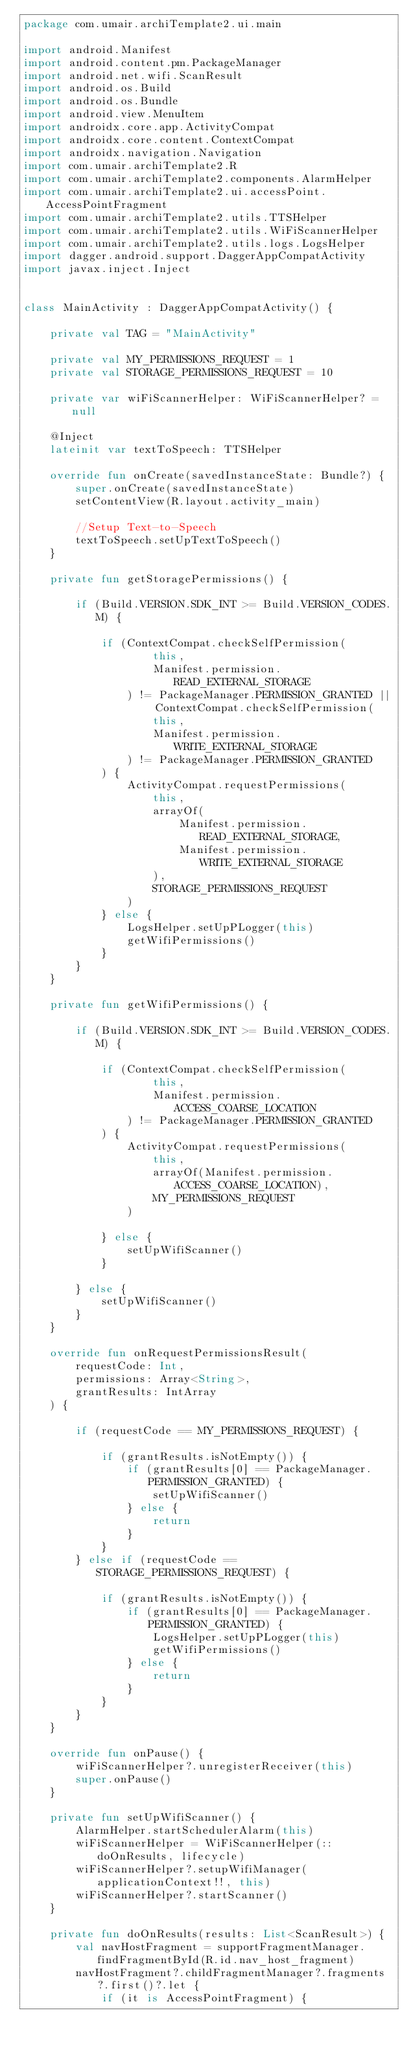<code> <loc_0><loc_0><loc_500><loc_500><_Kotlin_>package com.umair.archiTemplate2.ui.main

import android.Manifest
import android.content.pm.PackageManager
import android.net.wifi.ScanResult
import android.os.Build
import android.os.Bundle
import android.view.MenuItem
import androidx.core.app.ActivityCompat
import androidx.core.content.ContextCompat
import androidx.navigation.Navigation
import com.umair.archiTemplate2.R
import com.umair.archiTemplate2.components.AlarmHelper
import com.umair.archiTemplate2.ui.accessPoint.AccessPointFragment
import com.umair.archiTemplate2.utils.TTSHelper
import com.umair.archiTemplate2.utils.WiFiScannerHelper
import com.umair.archiTemplate2.utils.logs.LogsHelper
import dagger.android.support.DaggerAppCompatActivity
import javax.inject.Inject


class MainActivity : DaggerAppCompatActivity() {

    private val TAG = "MainActivity"

    private val MY_PERMISSIONS_REQUEST = 1
    private val STORAGE_PERMISSIONS_REQUEST = 10

    private var wiFiScannerHelper: WiFiScannerHelper? = null

    @Inject
    lateinit var textToSpeech: TTSHelper

    override fun onCreate(savedInstanceState: Bundle?) {
        super.onCreate(savedInstanceState)
        setContentView(R.layout.activity_main)

        //Setup Text-to-Speech
        textToSpeech.setUpTextToSpeech()
    }

    private fun getStoragePermissions() {

        if (Build.VERSION.SDK_INT >= Build.VERSION_CODES.M) {

            if (ContextCompat.checkSelfPermission(
                    this,
                    Manifest.permission.READ_EXTERNAL_STORAGE
                ) != PackageManager.PERMISSION_GRANTED || ContextCompat.checkSelfPermission(
                    this,
                    Manifest.permission.WRITE_EXTERNAL_STORAGE
                ) != PackageManager.PERMISSION_GRANTED
            ) {
                ActivityCompat.requestPermissions(
                    this,
                    arrayOf(
                        Manifest.permission.READ_EXTERNAL_STORAGE,
                        Manifest.permission.WRITE_EXTERNAL_STORAGE
                    ),
                    STORAGE_PERMISSIONS_REQUEST
                )
            } else {
                LogsHelper.setUpPLogger(this)
                getWifiPermissions()
            }
        }
    }

    private fun getWifiPermissions() {

        if (Build.VERSION.SDK_INT >= Build.VERSION_CODES.M) {

            if (ContextCompat.checkSelfPermission(
                    this,
                    Manifest.permission.ACCESS_COARSE_LOCATION
                ) != PackageManager.PERMISSION_GRANTED
            ) {
                ActivityCompat.requestPermissions(
                    this,
                    arrayOf(Manifest.permission.ACCESS_COARSE_LOCATION),
                    MY_PERMISSIONS_REQUEST
                )

            } else {
                setUpWifiScanner()
            }

        } else {
            setUpWifiScanner()
        }
    }

    override fun onRequestPermissionsResult(
        requestCode: Int,
        permissions: Array<String>,
        grantResults: IntArray
    ) {

        if (requestCode == MY_PERMISSIONS_REQUEST) {

            if (grantResults.isNotEmpty()) {
                if (grantResults[0] == PackageManager.PERMISSION_GRANTED) {
                    setUpWifiScanner()
                } else {
                    return
                }
            }
        } else if (requestCode == STORAGE_PERMISSIONS_REQUEST) {

            if (grantResults.isNotEmpty()) {
                if (grantResults[0] == PackageManager.PERMISSION_GRANTED) {
                    LogsHelper.setUpPLogger(this)
                    getWifiPermissions()
                } else {
                    return
                }
            }
        }
    }

    override fun onPause() {
        wiFiScannerHelper?.unregisterReceiver(this)
        super.onPause()
    }

    private fun setUpWifiScanner() {
        AlarmHelper.startSchedulerAlarm(this)
        wiFiScannerHelper = WiFiScannerHelper(::doOnResults, lifecycle)
        wiFiScannerHelper?.setupWifiManager(applicationContext!!, this)
        wiFiScannerHelper?.startScanner()
    }

    private fun doOnResults(results: List<ScanResult>) {
        val navHostFragment = supportFragmentManager.findFragmentById(R.id.nav_host_fragment)
        navHostFragment?.childFragmentManager?.fragments?.first()?.let {
            if (it is AccessPointFragment) {</code> 